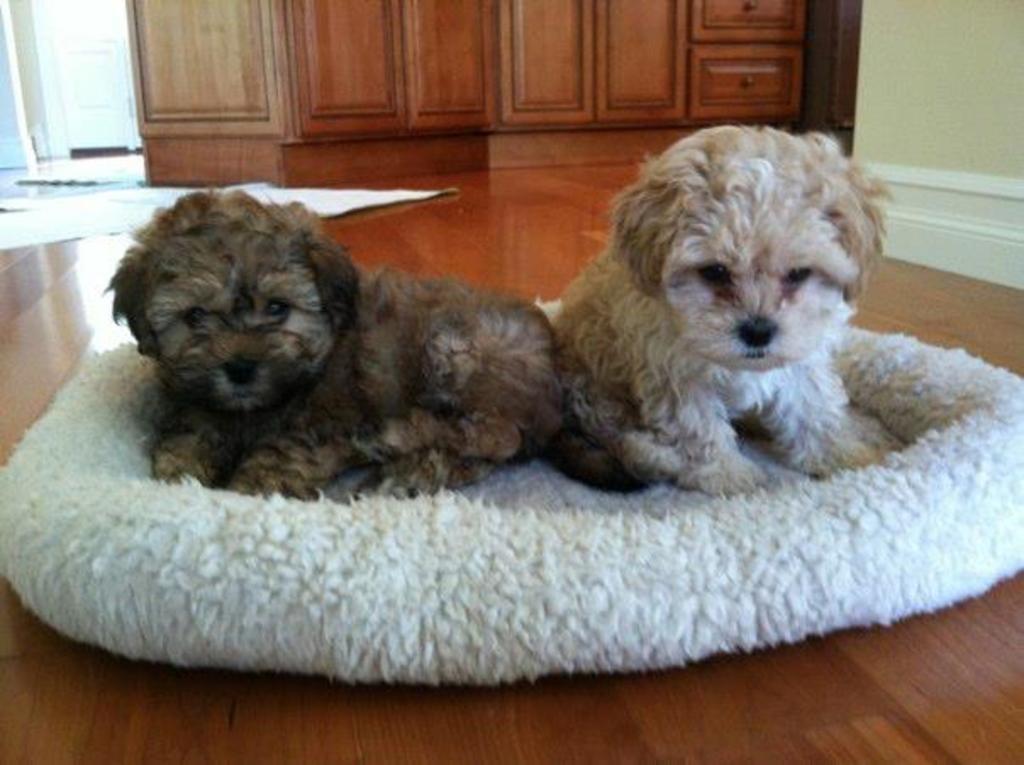In one or two sentences, can you explain what this image depicts? In this image we can see the dogs on the floor which is on the floor. We can also see the wall, cupboards and also the mats in the background. 